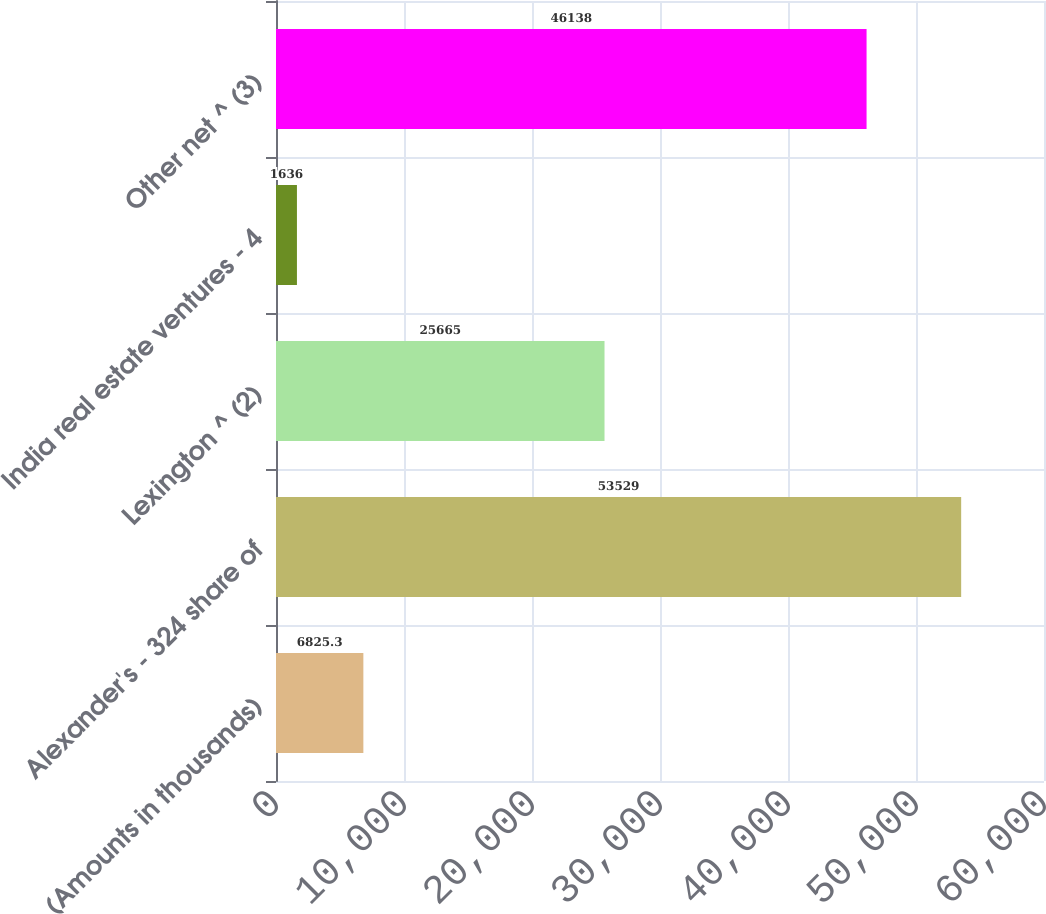Convert chart to OTSL. <chart><loc_0><loc_0><loc_500><loc_500><bar_chart><fcel>(Amounts in thousands)<fcel>Alexander's - 324 share of<fcel>Lexington ^ (2)<fcel>India real estate ventures - 4<fcel>Other net ^ (3)<nl><fcel>6825.3<fcel>53529<fcel>25665<fcel>1636<fcel>46138<nl></chart> 